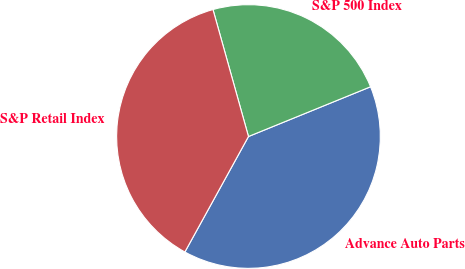Convert chart to OTSL. <chart><loc_0><loc_0><loc_500><loc_500><pie_chart><fcel>Advance Auto Parts<fcel>S&P 500 Index<fcel>S&P Retail Index<nl><fcel>39.17%<fcel>23.18%<fcel>37.65%<nl></chart> 